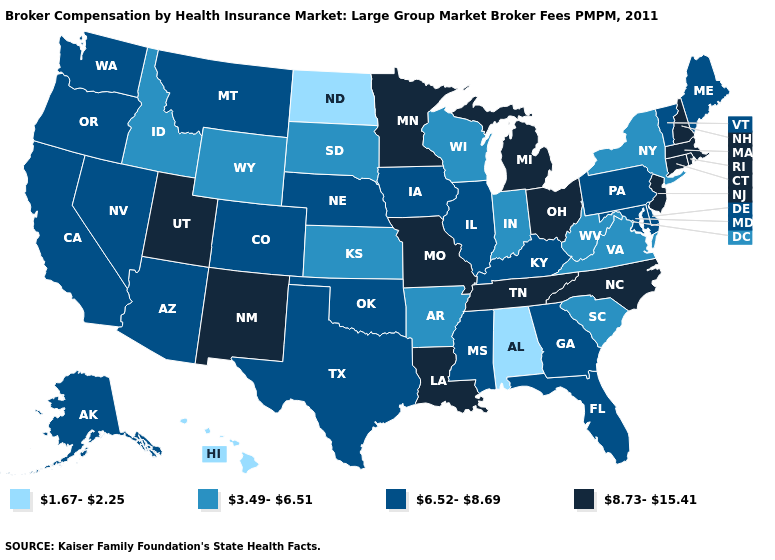What is the value of Indiana?
Short answer required. 3.49-6.51. Does New York have the highest value in the Northeast?
Keep it brief. No. Name the states that have a value in the range 1.67-2.25?
Be succinct. Alabama, Hawaii, North Dakota. Does Alabama have the lowest value in the USA?
Give a very brief answer. Yes. What is the value of California?
Quick response, please. 6.52-8.69. Does Rhode Island have the highest value in the USA?
Answer briefly. Yes. Name the states that have a value in the range 3.49-6.51?
Answer briefly. Arkansas, Idaho, Indiana, Kansas, New York, South Carolina, South Dakota, Virginia, West Virginia, Wisconsin, Wyoming. Does New Jersey have the lowest value in the Northeast?
Quick response, please. No. What is the value of Vermont?
Concise answer only. 6.52-8.69. Name the states that have a value in the range 6.52-8.69?
Be succinct. Alaska, Arizona, California, Colorado, Delaware, Florida, Georgia, Illinois, Iowa, Kentucky, Maine, Maryland, Mississippi, Montana, Nebraska, Nevada, Oklahoma, Oregon, Pennsylvania, Texas, Vermont, Washington. Name the states that have a value in the range 6.52-8.69?
Quick response, please. Alaska, Arizona, California, Colorado, Delaware, Florida, Georgia, Illinois, Iowa, Kentucky, Maine, Maryland, Mississippi, Montana, Nebraska, Nevada, Oklahoma, Oregon, Pennsylvania, Texas, Vermont, Washington. Which states have the lowest value in the Northeast?
Answer briefly. New York. What is the value of Georgia?
Quick response, please. 6.52-8.69. What is the value of Arizona?
Keep it brief. 6.52-8.69. 